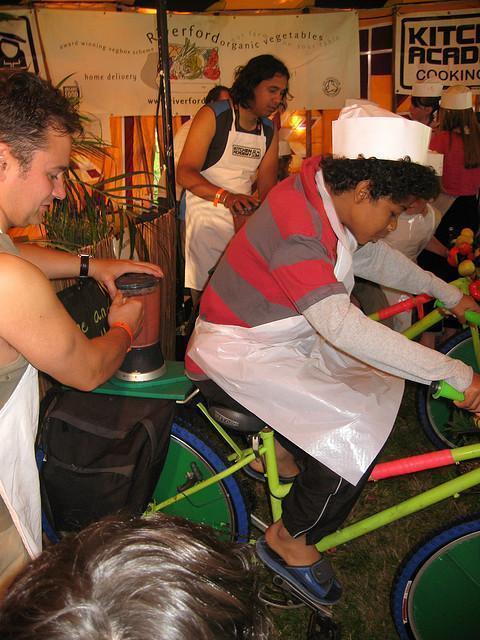What does the person in the white hat power?
From the following four choices, select the correct answer to address the question.
Options: Nothing, blender, forward movement, aerobic. Blender. 